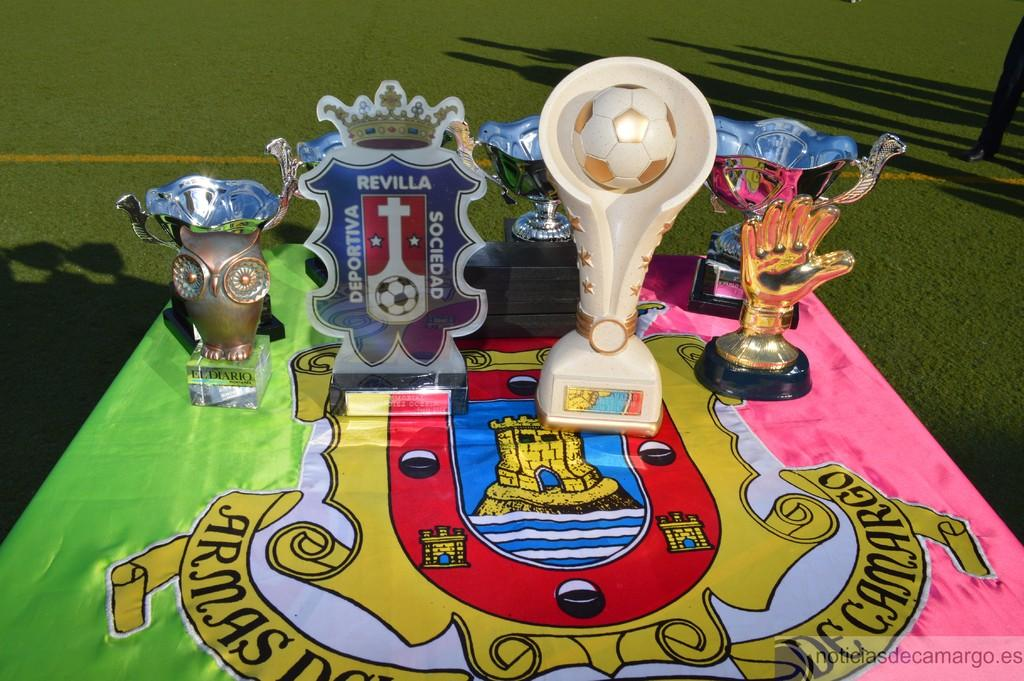<image>
Describe the image concisely. Many trophies are on a table, including one that says "el diario". 